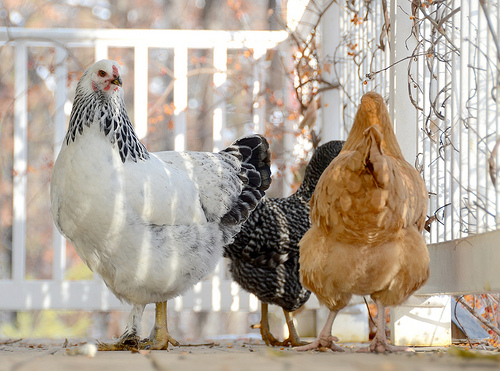<image>
Can you confirm if the white hen is on the black hen? No. The white hen is not positioned on the black hen. They may be near each other, but the white hen is not supported by or resting on top of the black hen. 